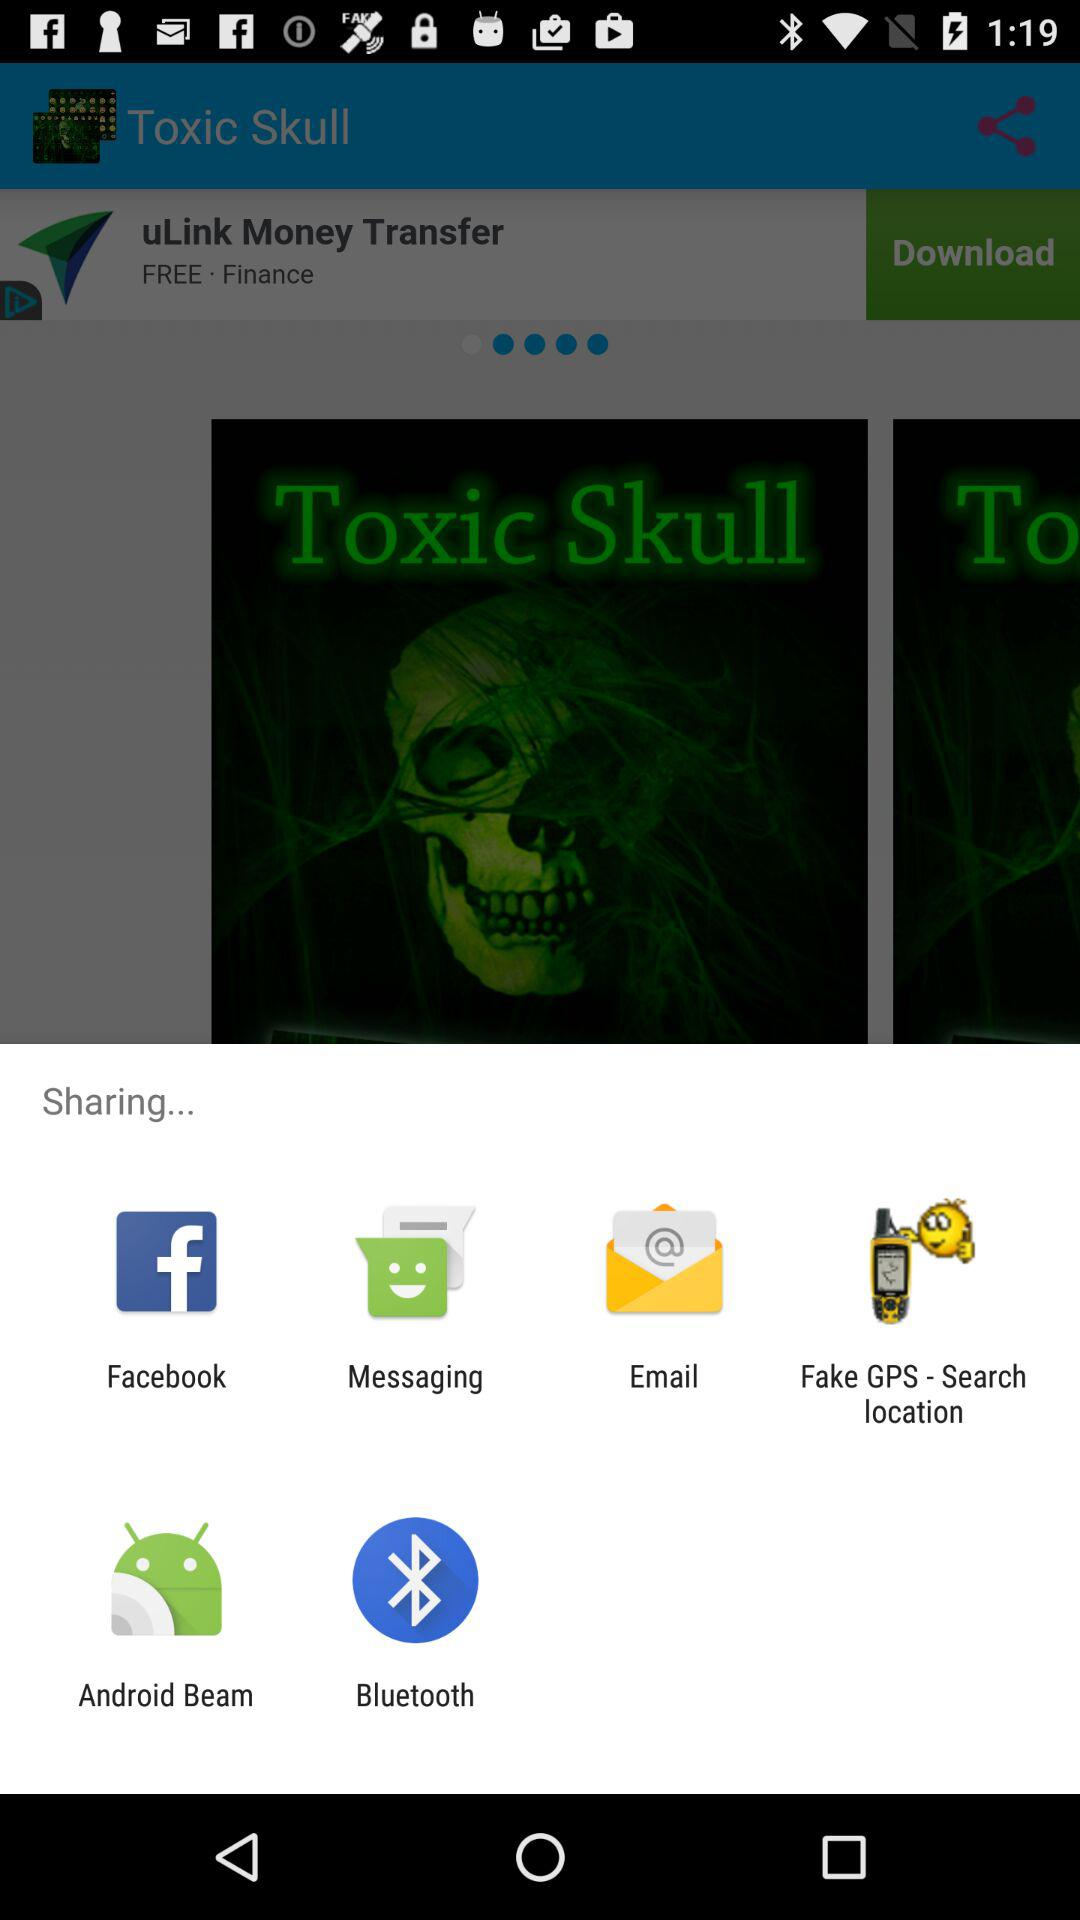What option is available for sharing? The available options for sharing are "Facebook", "Messaging", "Email", "Fake GPS - Search location", "Android Beam" and "Bluetooth". 